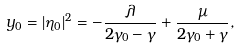<formula> <loc_0><loc_0><loc_500><loc_500>y _ { 0 } = | \eta _ { 0 } | ^ { 2 } = - \frac { \lambda } { 2 \gamma _ { 0 } - \gamma } + \frac { \mu } { 2 \gamma _ { 0 } + \gamma } ,</formula> 